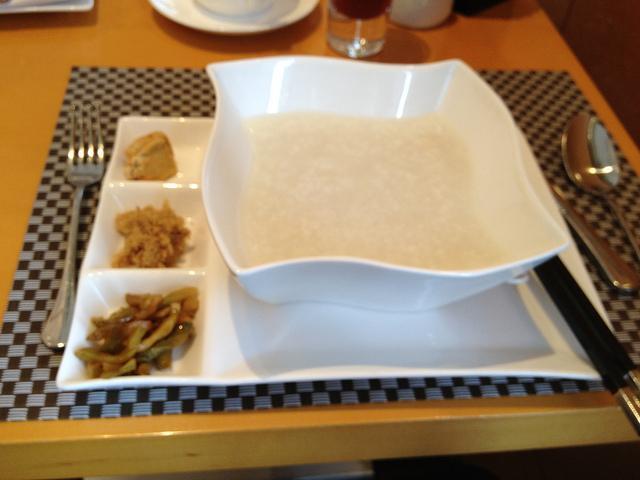How many sides are there to the dish?
Give a very brief answer. 3. How many knives can be seen?
Give a very brief answer. 2. 